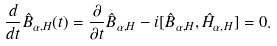<formula> <loc_0><loc_0><loc_500><loc_500>\frac { d } { d t } \hat { B } _ { \alpha , H } ( t ) = \frac { \partial } { \partial t } \hat { B } _ { \alpha , H } - i [ \hat { B } _ { \alpha , H } , \hat { H } _ { \alpha , H } ] = 0 .</formula> 